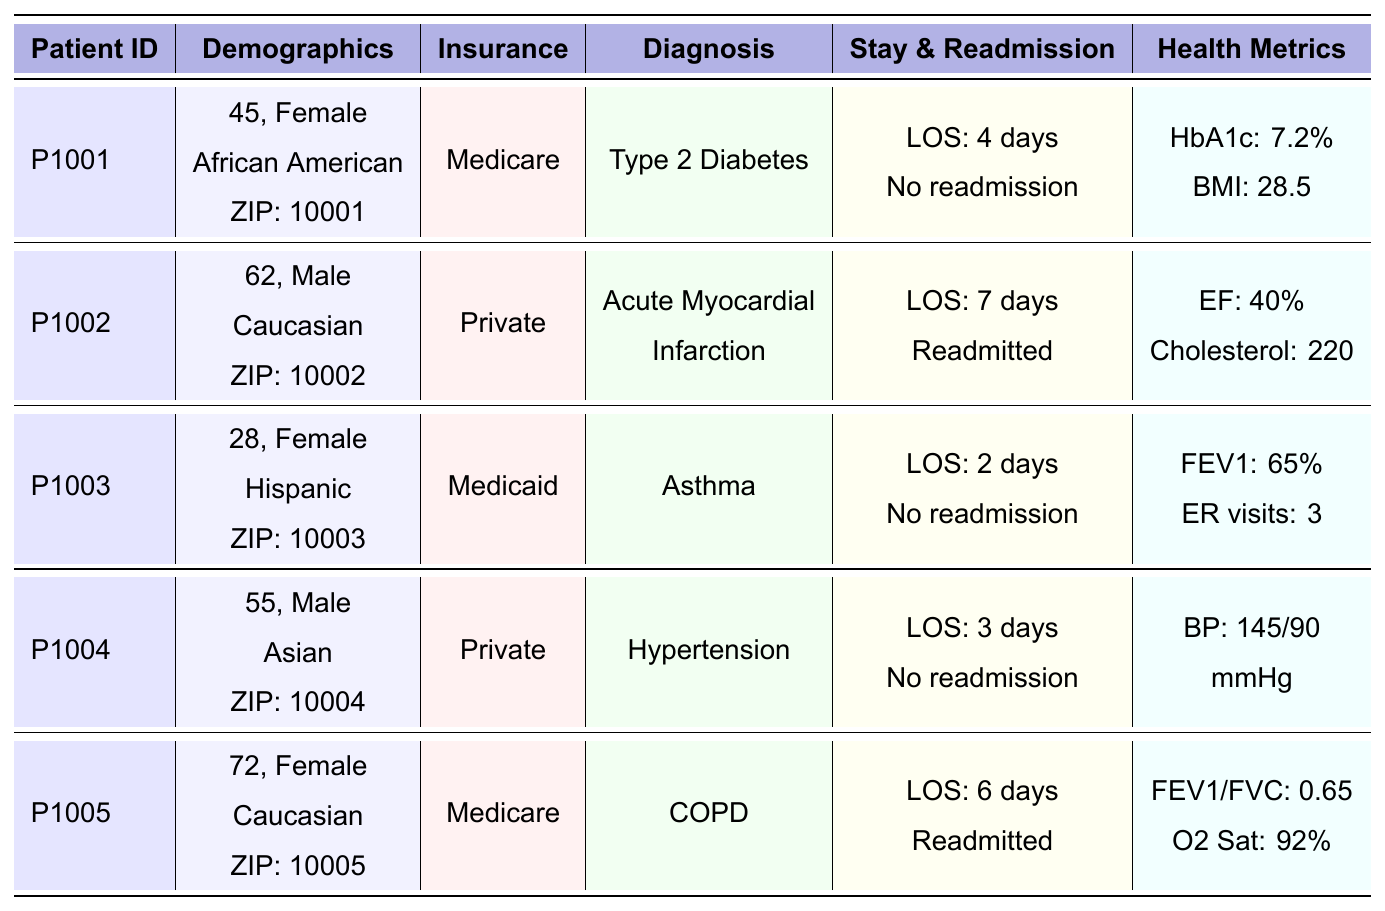What is the age of the patient with the primary diagnosis of Type 2 Diabetes? The patient with the diagnosis of Type 2 Diabetes is identified as P1001. Referring to the demographic details, P1001 is 45 years old.
Answer: 45 How many patients were readmitted within 30 days? By reviewing the "Readmission" column, P1002 and P1005 are marked as true for readmission, meaning there are 2 patients who were readmitted within 30 days.
Answer: 2 What is the average length of stay for all patients? The lengths of stay for the patients are 4, 7, 2, 3, and 6 days. To find the average, calculate the sum: 4 + 7 + 2 + 3 + 6 = 22. Then divide by the number of patients (5): 22 / 5 = 4.4 days.
Answer: 4.4 days Is there any female patient with a BMI greater than 30? P1001 has a BMI of 28.5, and P1005 has a BMI value that is not provided directly but may be inferred as concerning COPD and being older with a higher likelihood of obesity. Since no value is stated for P1005, it leads to the conclusion that currently available data shows no female with a BMI above 30.
Answer: No What is the highest age among the patients diagnosed with a chronic condition? Chronic conditions here would include Type 2 Diabetes, Acute Myocardial Infarction, Asthma, Hypertension, and COPD. The ages for these diagnoses are 45, 62, 28, 55, and 72 respectively. The highest age is from the patient with COPD (P1005) at 72 years old.
Answer: 72 Which patient has the lowest HbA1c level, and what is that level? The only patient with an HbA1c level mentioned is P1001 with a level of 7.2%. There are no others listed in the data, hence P1001 has the lowest HbA1c level.
Answer: P1001, 7.2% How many emergency visits did the female patient with asthma have in the last year? The female patient diagnosed with asthma is P1003, whose record indicates she had 3 emergency visits in the last year.
Answer: 3 What is the relationship between insurance type and readmission for Medicare patients? Among Medicare patients, P1001 was not readmitted (no) while P1005 was readmitted (yes). Thus, both patients had different outcomes related to insurance type where P1005 showed readmission after a readmission under Medicare.
Answer: Mixed outcomes What is the average cholesterol level for patients with heart-related issues like myocardial infarction? The only patient with a diagnosis related to heart issues is P1002, who has a cholesterol level of 220. Given we only consider this one data point, the average is equal to the cholesterol value.
Answer: 220 Do all patients have a documented zip code? Referring to each patient in the table, every patient (P1001, P1002, P1003, P1004, P1005) has a listed zip code. Therefore, all patients indeed have documented zip codes.
Answer: Yes 